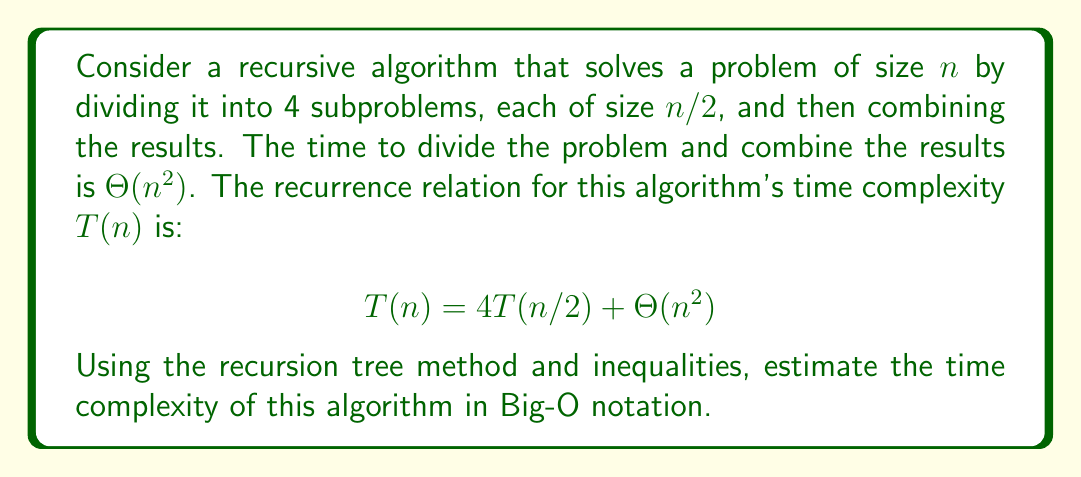Can you solve this math problem? Let's approach this step-by-step:

1) First, we'll construct a recursion tree to visualize the problem:

   Level 0:         $cn^2$
   Level 1:     4 * $c(n/2)^2$
   Level 2: 16 * $c(n/4)^2$
   ...
   Level $\log_2 n$: $4^{\log_2 n}$ * $c(1)^2$

   Where c is a constant.

2) Now, let's calculate the cost at each level:

   Level 0: $cn^2$
   Level 1: $4c(n/2)^2 = cn^2$
   Level 2: $16c(n/4)^2 = cn^2$
   ...
   Level $\log_2 n$: $4^{\log_2 n} * c(1)^2 = n^2c$

3) We can see that each level contributes $cn^2$ to the total cost.

4) The number of levels in the tree is $\log_2 n + 1$.

5) Therefore, we can bound the total cost T(n) as follows:

   $T(n) \leq cn^2 * (\log_2 n + 1)$

6) This can be simplified to:

   $T(n) = O(n^2 \log n)$

7) To prove this is a tight bound, we can also show that:

   $T(n) \geq cn^2 * (\log_2 n + 1)$

   Which gives us:

   $T(n) = \Omega(n^2 \log n)$

8) Combining the upper and lower bounds:

   $T(n) = \Theta(n^2 \log n)$
Answer: The time complexity of the algorithm is $O(n^2 \log n)$. 